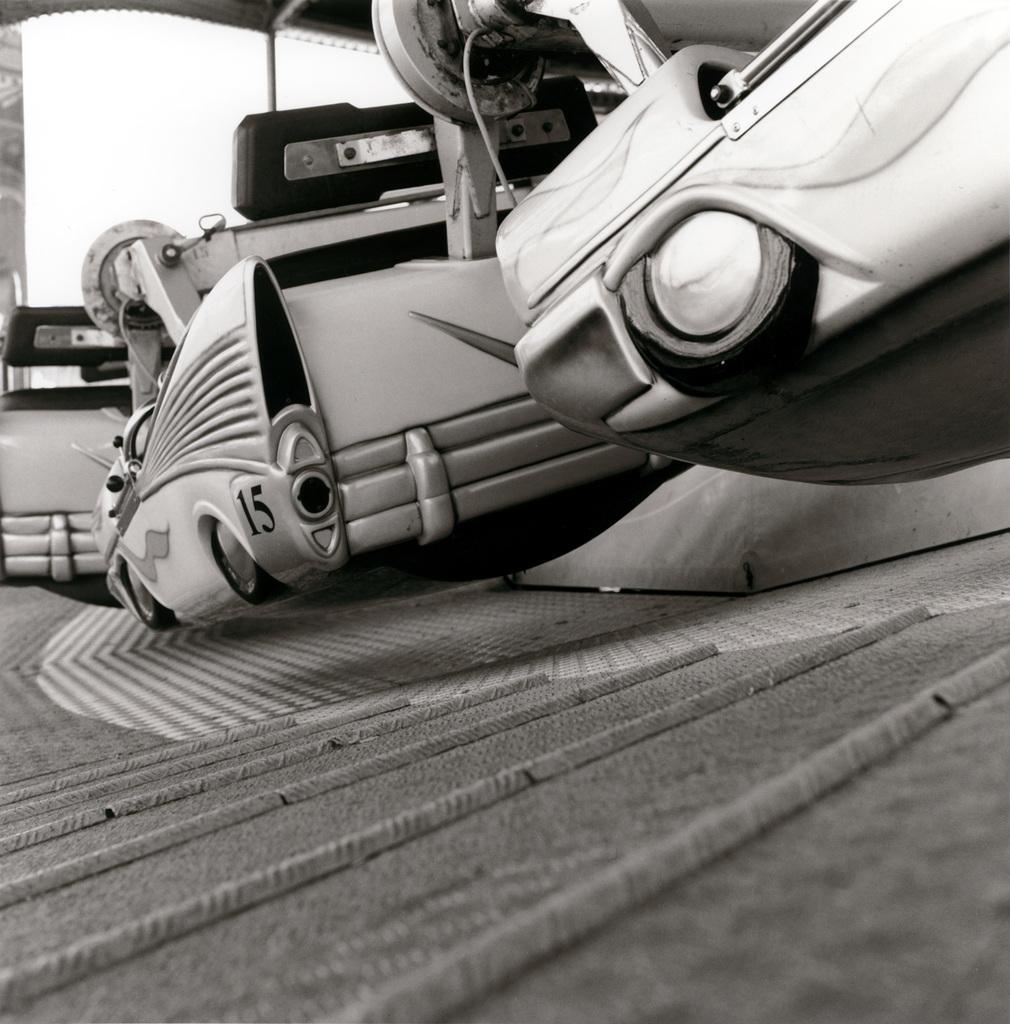Could you give a brief overview of what you see in this image? It is a black and white image and in the center there is an object with number fifteen on it. 